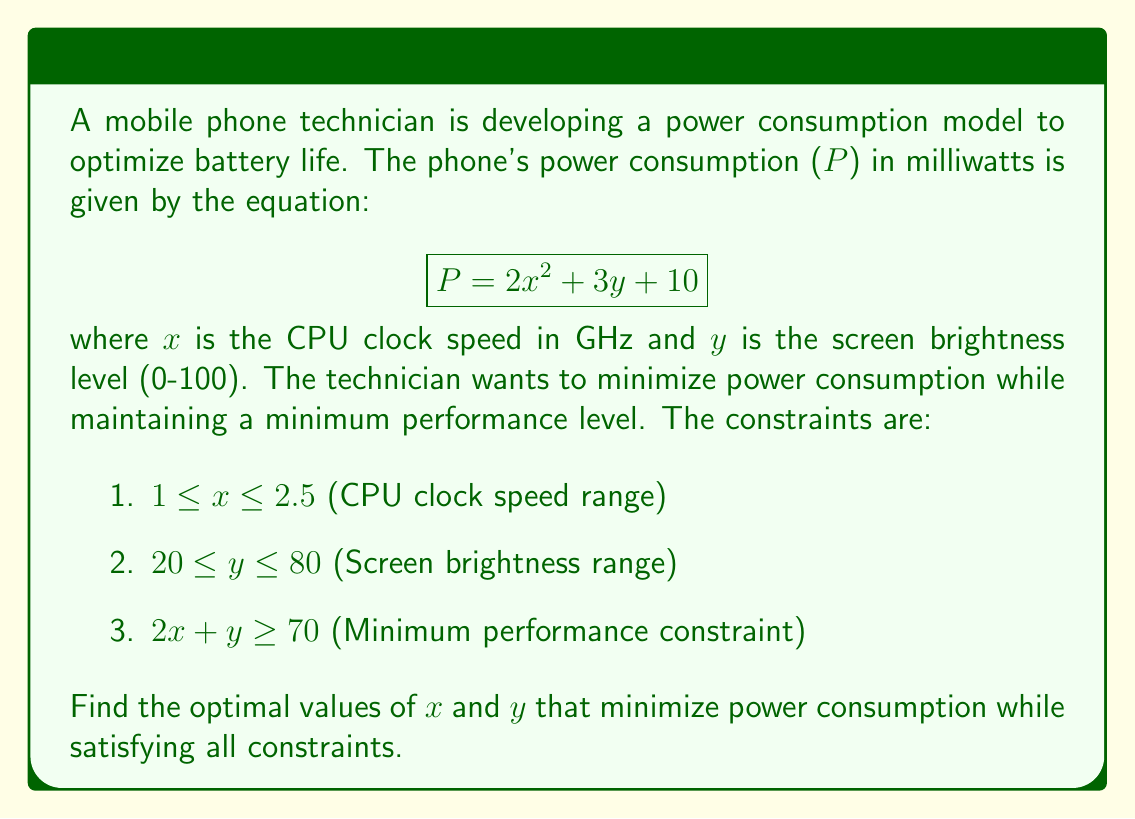Can you solve this math problem? To solve this optimization problem, we'll use the method of Lagrange multipliers:

1. Form the Lagrangian function:
   $$L(x, y, \lambda_1, \lambda_2, \lambda_3, \lambda_4, \lambda_5) = 2x^2 + 3y + 10 + \lambda_1(1-x) + \lambda_2(x-2.5) + \lambda_3(20-y) + \lambda_4(y-80) + \lambda_5(70-2x-y)$$

2. Set partial derivatives to zero:
   $$\frac{\partial L}{\partial x} = 4x - \lambda_1 + \lambda_2 - 2\lambda_5 = 0$$
   $$\frac{\partial L}{\partial y} = 3 - \lambda_3 + \lambda_4 - \lambda_5 = 0$$

3. Consider KKT conditions:
   $$\lambda_1(1-x) = 0, \lambda_2(x-2.5) = 0, \lambda_3(20-y) = 0, \lambda_4(y-80) = 0, \lambda_5(70-2x-y) = 0$$

4. Analyze possible cases:
   Case 1: If $\lambda_5 = 0$, then $4x = \lambda_1 - \lambda_2$ and $3 = \lambda_3 - \lambda_4$. This implies x = 1 and y = 20, but this violates the performance constraint.
   
   Case 2: If $\lambda_5 \neq 0$, then $2x + y = 70$ (active constraint).

5. Solve using the active constraint:
   Substitute $y = 70 - 2x$ into the objective function:
   $$P = 2x^2 + 3(70-2x) + 10 = 2x^2 - 6x + 220$$

6. Find the minimum of this quadratic function:
   $$\frac{dP}{dx} = 4x - 6 = 0$$
   $$x = 1.5$$

7. Calculate y:
   $$y = 70 - 2(1.5) = 67$$

8. Verify constraints:
   $1 \leq 1.5 \leq 2.5$ (satisfied)
   $20 \leq 67 \leq 80$ (satisfied)
   $2(1.5) + 67 = 70$ (satisfied)

Therefore, the optimal solution is x = 1.5 GHz and y = 67.
Answer: The optimal values are:
CPU clock speed (x) = 1.5 GHz
Screen brightness (y) = 67

Minimum power consumption: P = 2(1.5^2) + 3(67) + 10 = 214.5 mW 